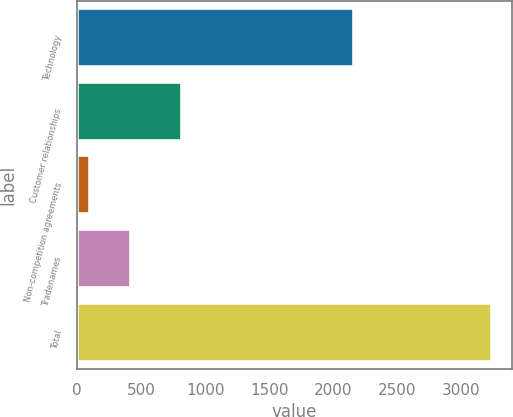Convert chart to OTSL. <chart><loc_0><loc_0><loc_500><loc_500><bar_chart><fcel>Technology<fcel>Customer relationships<fcel>Non-competition agreements<fcel>Tradenames<fcel>Total<nl><fcel>2159<fcel>816<fcel>106<fcel>418.8<fcel>3234<nl></chart> 